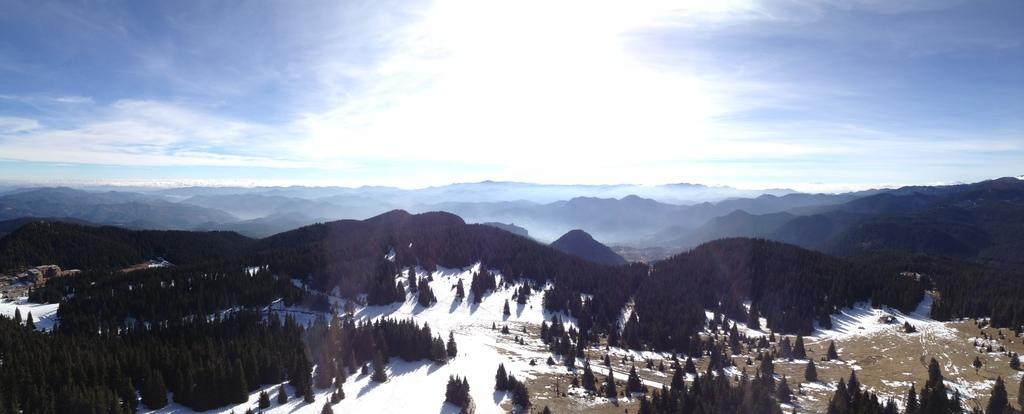How would you summarize this image in a sentence or two? In this image I can see the snow, few trees in green color. In the background I can see the mountains and the sky is in blue and white color. 